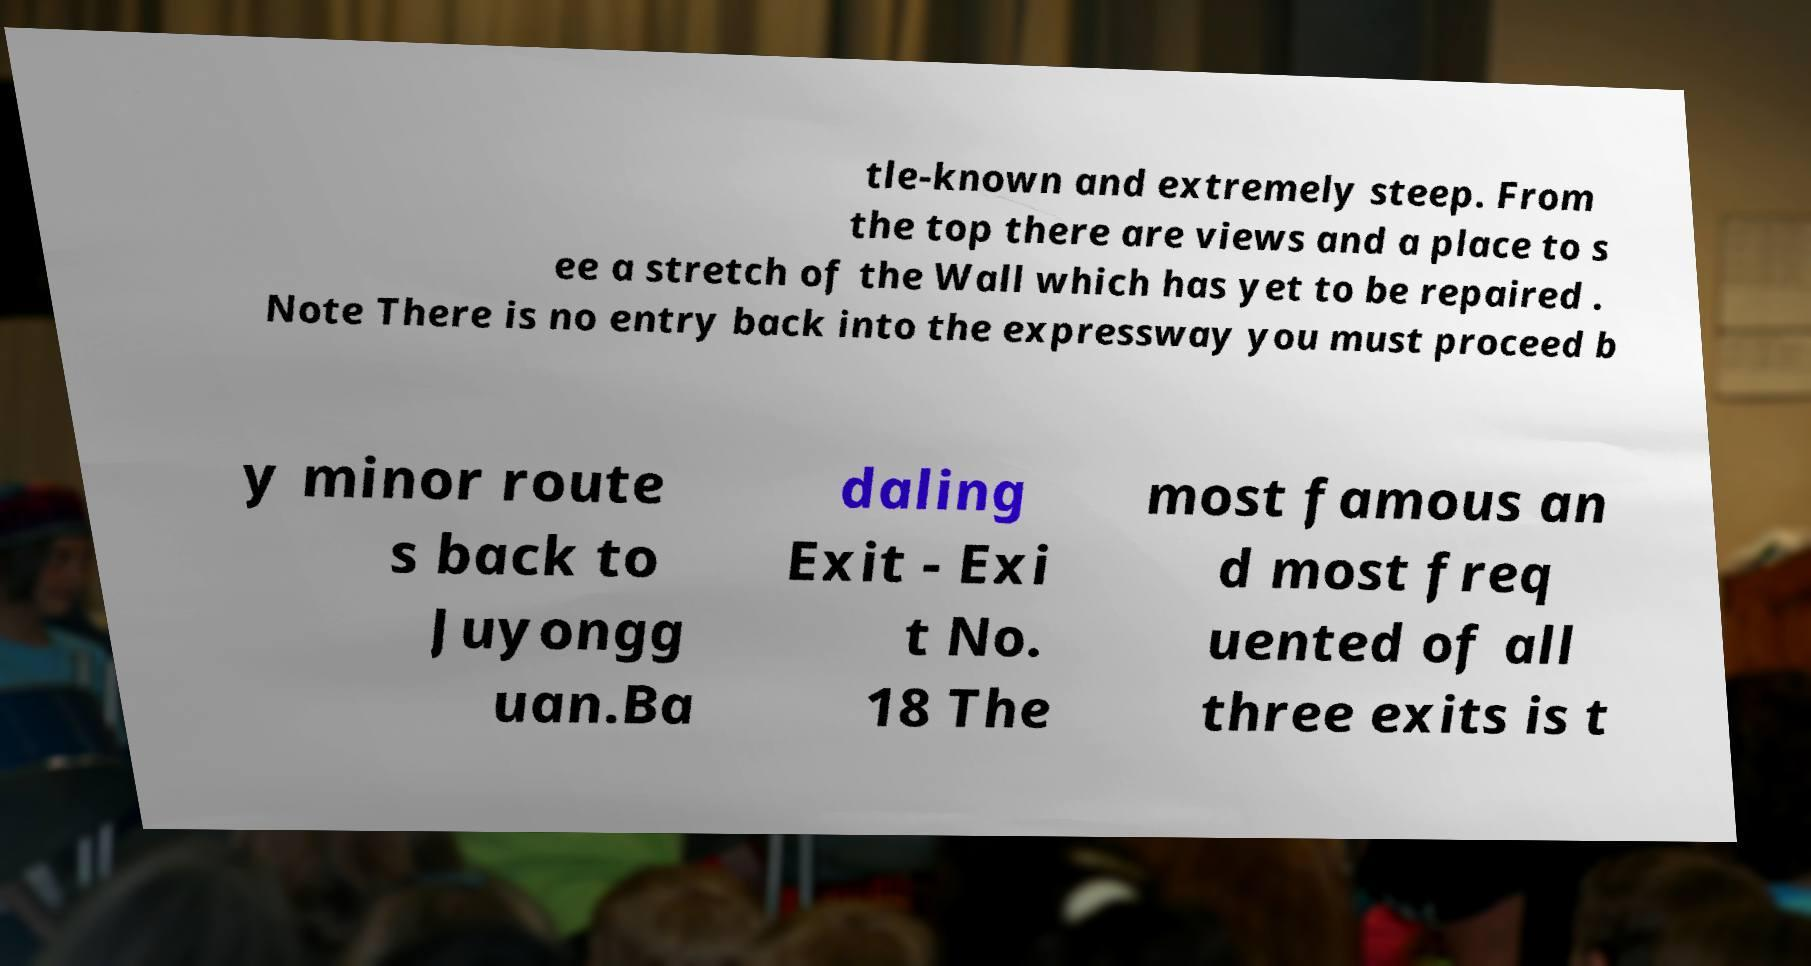Can you read and provide the text displayed in the image?This photo seems to have some interesting text. Can you extract and type it out for me? tle-known and extremely steep. From the top there are views and a place to s ee a stretch of the Wall which has yet to be repaired . Note There is no entry back into the expressway you must proceed b y minor route s back to Juyongg uan.Ba daling Exit - Exi t No. 18 The most famous an d most freq uented of all three exits is t 